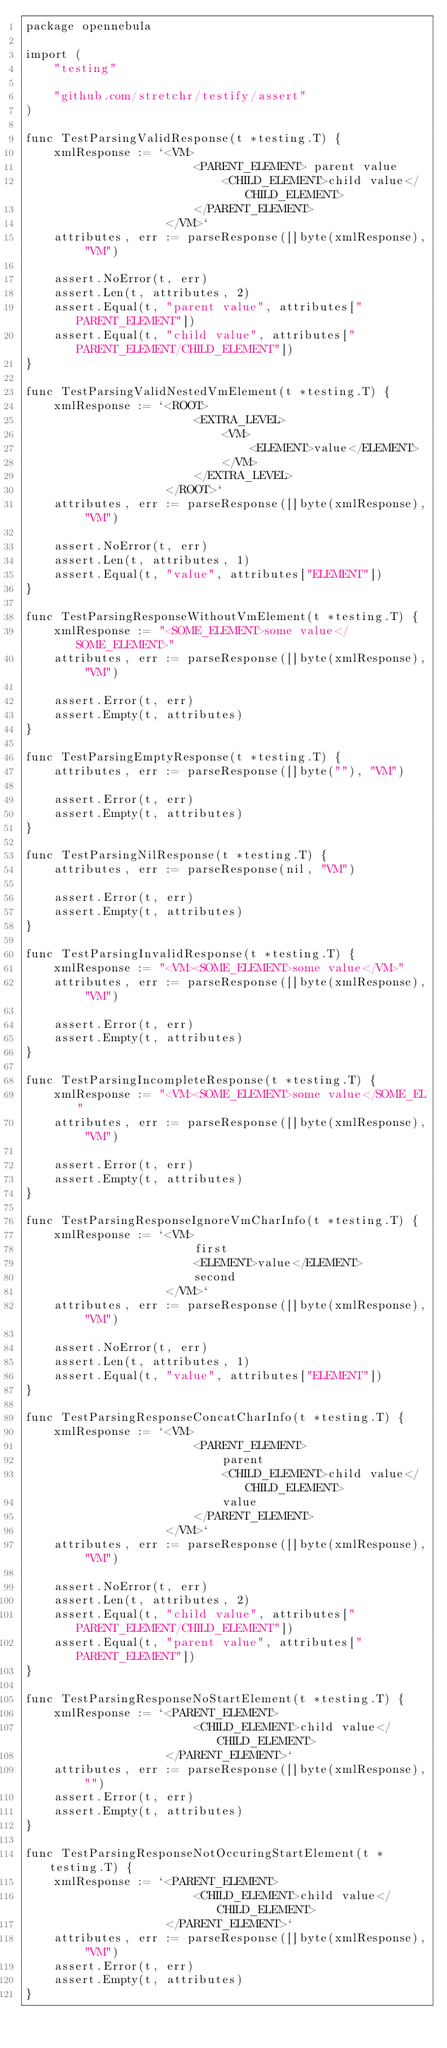<code> <loc_0><loc_0><loc_500><loc_500><_Go_>package opennebula

import (
	"testing"

	"github.com/stretchr/testify/assert"
)

func TestParsingValidResponse(t *testing.T) {
	xmlResponse := `<VM>
						<PARENT_ELEMENT> parent value
							<CHILD_ELEMENT>child value</CHILD_ELEMENT>
						</PARENT_ELEMENT>
					</VM>`
	attributes, err := parseResponse([]byte(xmlResponse), "VM")

	assert.NoError(t, err)
	assert.Len(t, attributes, 2)
	assert.Equal(t, "parent value", attributes["PARENT_ELEMENT"])
	assert.Equal(t, "child value", attributes["PARENT_ELEMENT/CHILD_ELEMENT"])
}

func TestParsingValidNestedVmElement(t *testing.T) {
	xmlResponse := `<ROOT>
						<EXTRA_LEVEL>
							<VM>
								<ELEMENT>value</ELEMENT>
							</VM>
						</EXTRA_LEVEL>
					</ROOT>`
	attributes, err := parseResponse([]byte(xmlResponse), "VM")

	assert.NoError(t, err)
	assert.Len(t, attributes, 1)
	assert.Equal(t, "value", attributes["ELEMENT"])
}

func TestParsingResponseWithoutVmElement(t *testing.T) {
	xmlResponse := "<SOME_ELEMENT>some value</SOME_ELEMENT>"
	attributes, err := parseResponse([]byte(xmlResponse), "VM")

	assert.Error(t, err)
	assert.Empty(t, attributes)
}

func TestParsingEmptyResponse(t *testing.T) {
	attributes, err := parseResponse([]byte(""), "VM")

	assert.Error(t, err)
	assert.Empty(t, attributes)
}

func TestParsingNilResponse(t *testing.T) {
	attributes, err := parseResponse(nil, "VM")

	assert.Error(t, err)
	assert.Empty(t, attributes)
}

func TestParsingInvalidResponse(t *testing.T) {
	xmlResponse := "<VM><SOME_ELEMENT>some value</VM>"
	attributes, err := parseResponse([]byte(xmlResponse), "VM")

	assert.Error(t, err)
	assert.Empty(t, attributes)
}

func TestParsingIncompleteResponse(t *testing.T) {
	xmlResponse := "<VM><SOME_ELEMENT>some value</SOME_EL"
	attributes, err := parseResponse([]byte(xmlResponse), "VM")

	assert.Error(t, err)
	assert.Empty(t, attributes)
}

func TestParsingResponseIgnoreVmCharInfo(t *testing.T) {
	xmlResponse := `<VM> 
						first
						<ELEMENT>value</ELEMENT>
						second
					</VM>`
	attributes, err := parseResponse([]byte(xmlResponse), "VM")

	assert.NoError(t, err)
	assert.Len(t, attributes, 1)
	assert.Equal(t, "value", attributes["ELEMENT"])
}

func TestParsingResponseConcatCharInfo(t *testing.T) {
	xmlResponse := `<VM> 
						<PARENT_ELEMENT> 
							parent
							<CHILD_ELEMENT>child value</CHILD_ELEMENT>
							value
						</PARENT_ELEMENT>
					</VM>`
	attributes, err := parseResponse([]byte(xmlResponse), "VM")

	assert.NoError(t, err)
	assert.Len(t, attributes, 2)
	assert.Equal(t, "child value", attributes["PARENT_ELEMENT/CHILD_ELEMENT"])
	assert.Equal(t, "parent value", attributes["PARENT_ELEMENT"])
}

func TestParsingResponseNoStartElement(t *testing.T) {
	xmlResponse := `<PARENT_ELEMENT>
						<CHILD_ELEMENT>child value</CHILD_ELEMENT>
					</PARENT_ELEMENT>`
	attributes, err := parseResponse([]byte(xmlResponse), "")
	assert.Error(t, err)
	assert.Empty(t, attributes)
}

func TestParsingResponseNotOccuringStartElement(t *testing.T) {
	xmlResponse := `<PARENT_ELEMENT>
						<CHILD_ELEMENT>child value</CHILD_ELEMENT>
					</PARENT_ELEMENT>`
	attributes, err := parseResponse([]byte(xmlResponse), "VM")
	assert.Error(t, err)
	assert.Empty(t, attributes)
}
</code> 